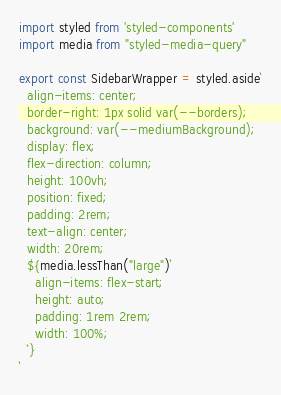Convert code to text. <code><loc_0><loc_0><loc_500><loc_500><_JavaScript_>import styled from 'styled-components'
import media from "styled-media-query"

export const SidebarWrapper = styled.aside`
  align-items: center;
  border-right: 1px solid var(--borders);
  background: var(--mediumBackground);
  display: flex;
  flex-direction: column;
  height: 100vh;
  position: fixed;
  padding: 2rem;
  text-align: center;
  width: 20rem;
  ${media.lessThan("large")`
    align-items: flex-start;
    height: auto;
    padding: 1rem 2rem;
    width: 100%;
  `}
`
</code> 